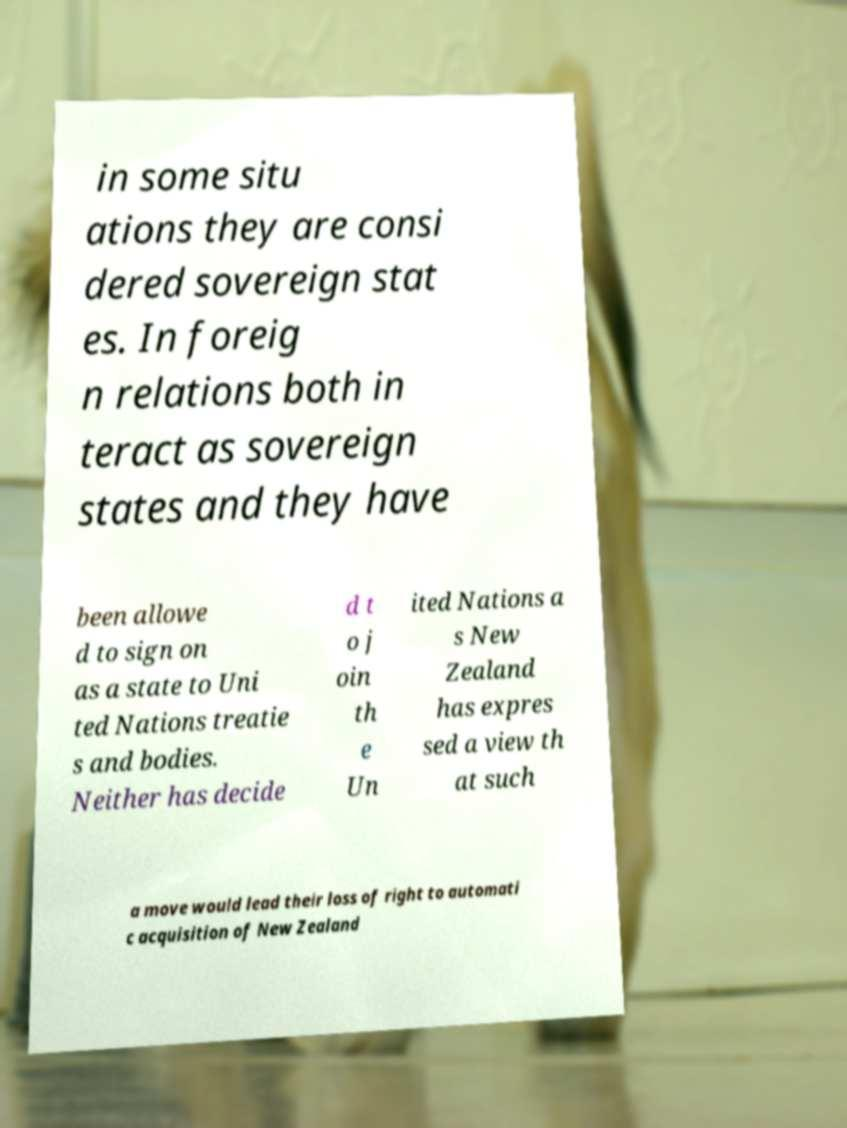Please read and relay the text visible in this image. What does it say? in some situ ations they are consi dered sovereign stat es. In foreig n relations both in teract as sovereign states and they have been allowe d to sign on as a state to Uni ted Nations treatie s and bodies. Neither has decide d t o j oin th e Un ited Nations a s New Zealand has expres sed a view th at such a move would lead their loss of right to automati c acquisition of New Zealand 